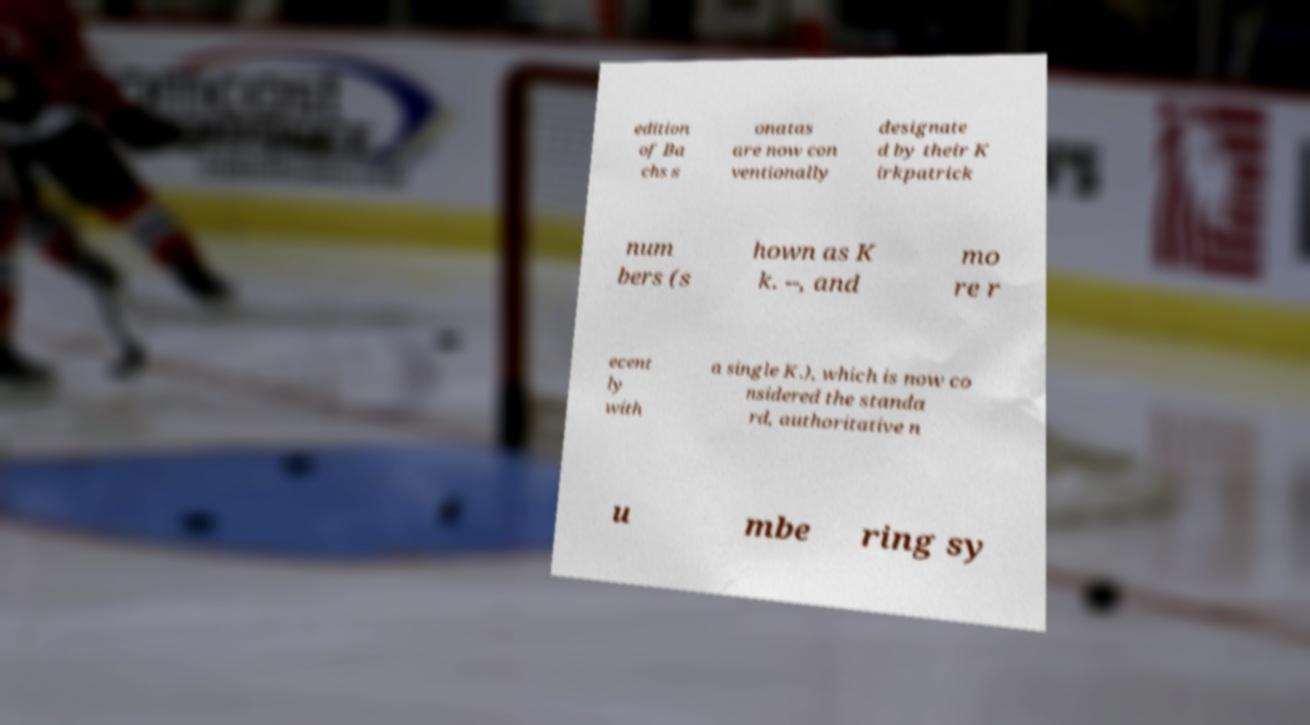For documentation purposes, I need the text within this image transcribed. Could you provide that? edition of Ba chs s onatas are now con ventionally designate d by their K irkpatrick num bers (s hown as K k. --, and mo re r ecent ly with a single K.), which is now co nsidered the standa rd, authoritative n u mbe ring sy 